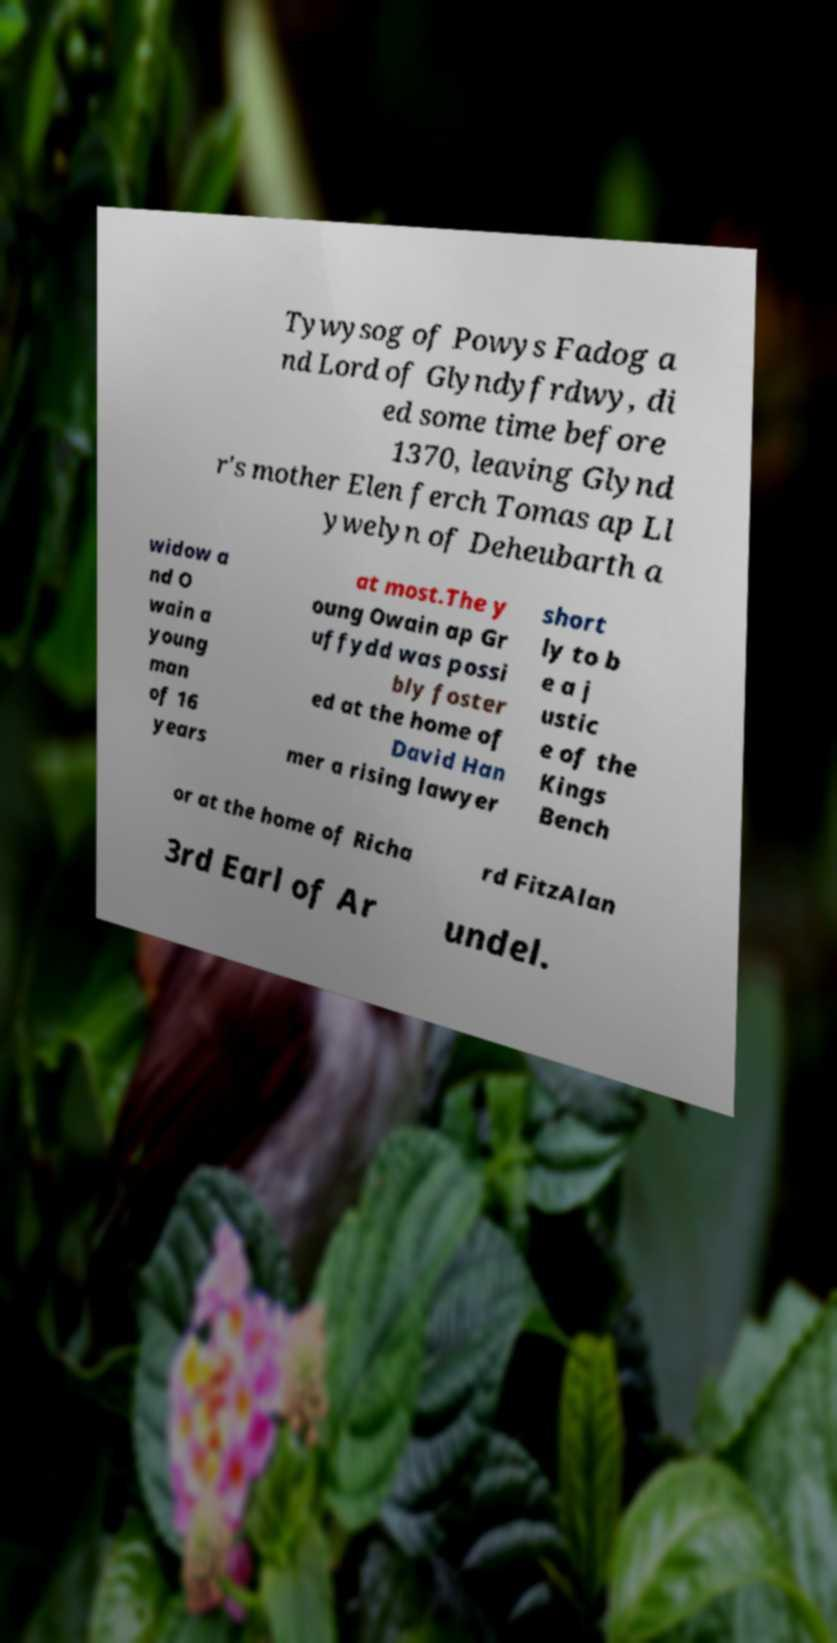There's text embedded in this image that I need extracted. Can you transcribe it verbatim? Tywysog of Powys Fadog a nd Lord of Glyndyfrdwy, di ed some time before 1370, leaving Glynd r's mother Elen ferch Tomas ap Ll ywelyn of Deheubarth a widow a nd O wain a young man of 16 years at most.The y oung Owain ap Gr uffydd was possi bly foster ed at the home of David Han mer a rising lawyer short ly to b e a j ustic e of the Kings Bench or at the home of Richa rd FitzAlan 3rd Earl of Ar undel. 